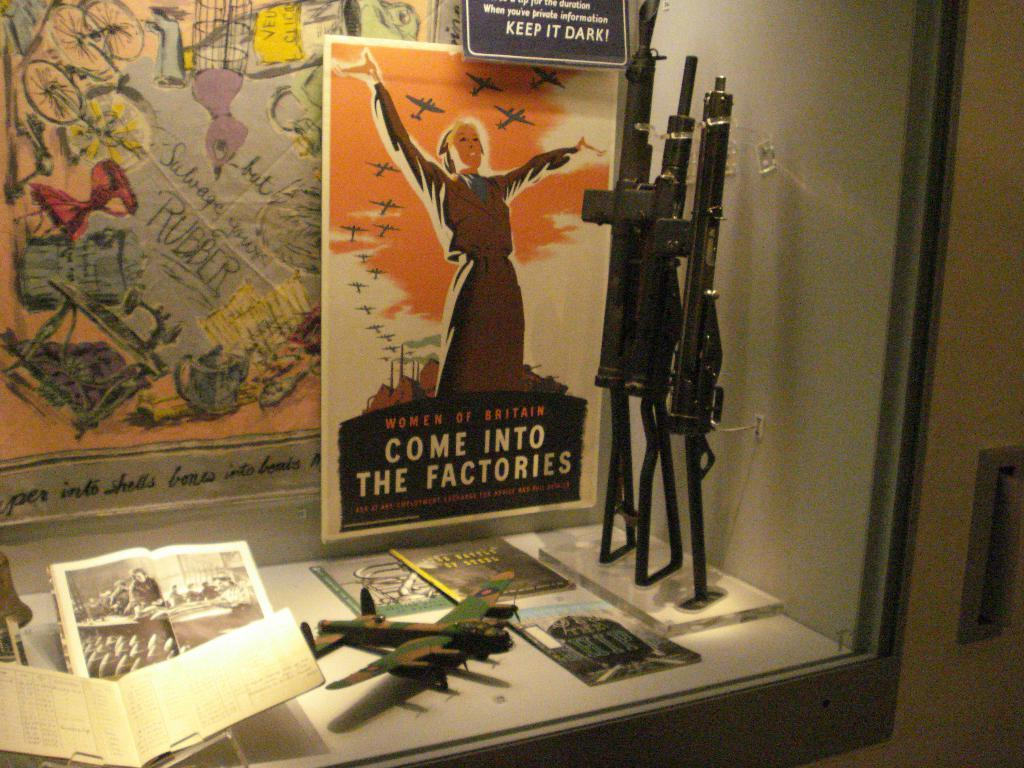<image>
Render a clear and concise summary of the photo. A poster of Women of Britain come into the factories. 